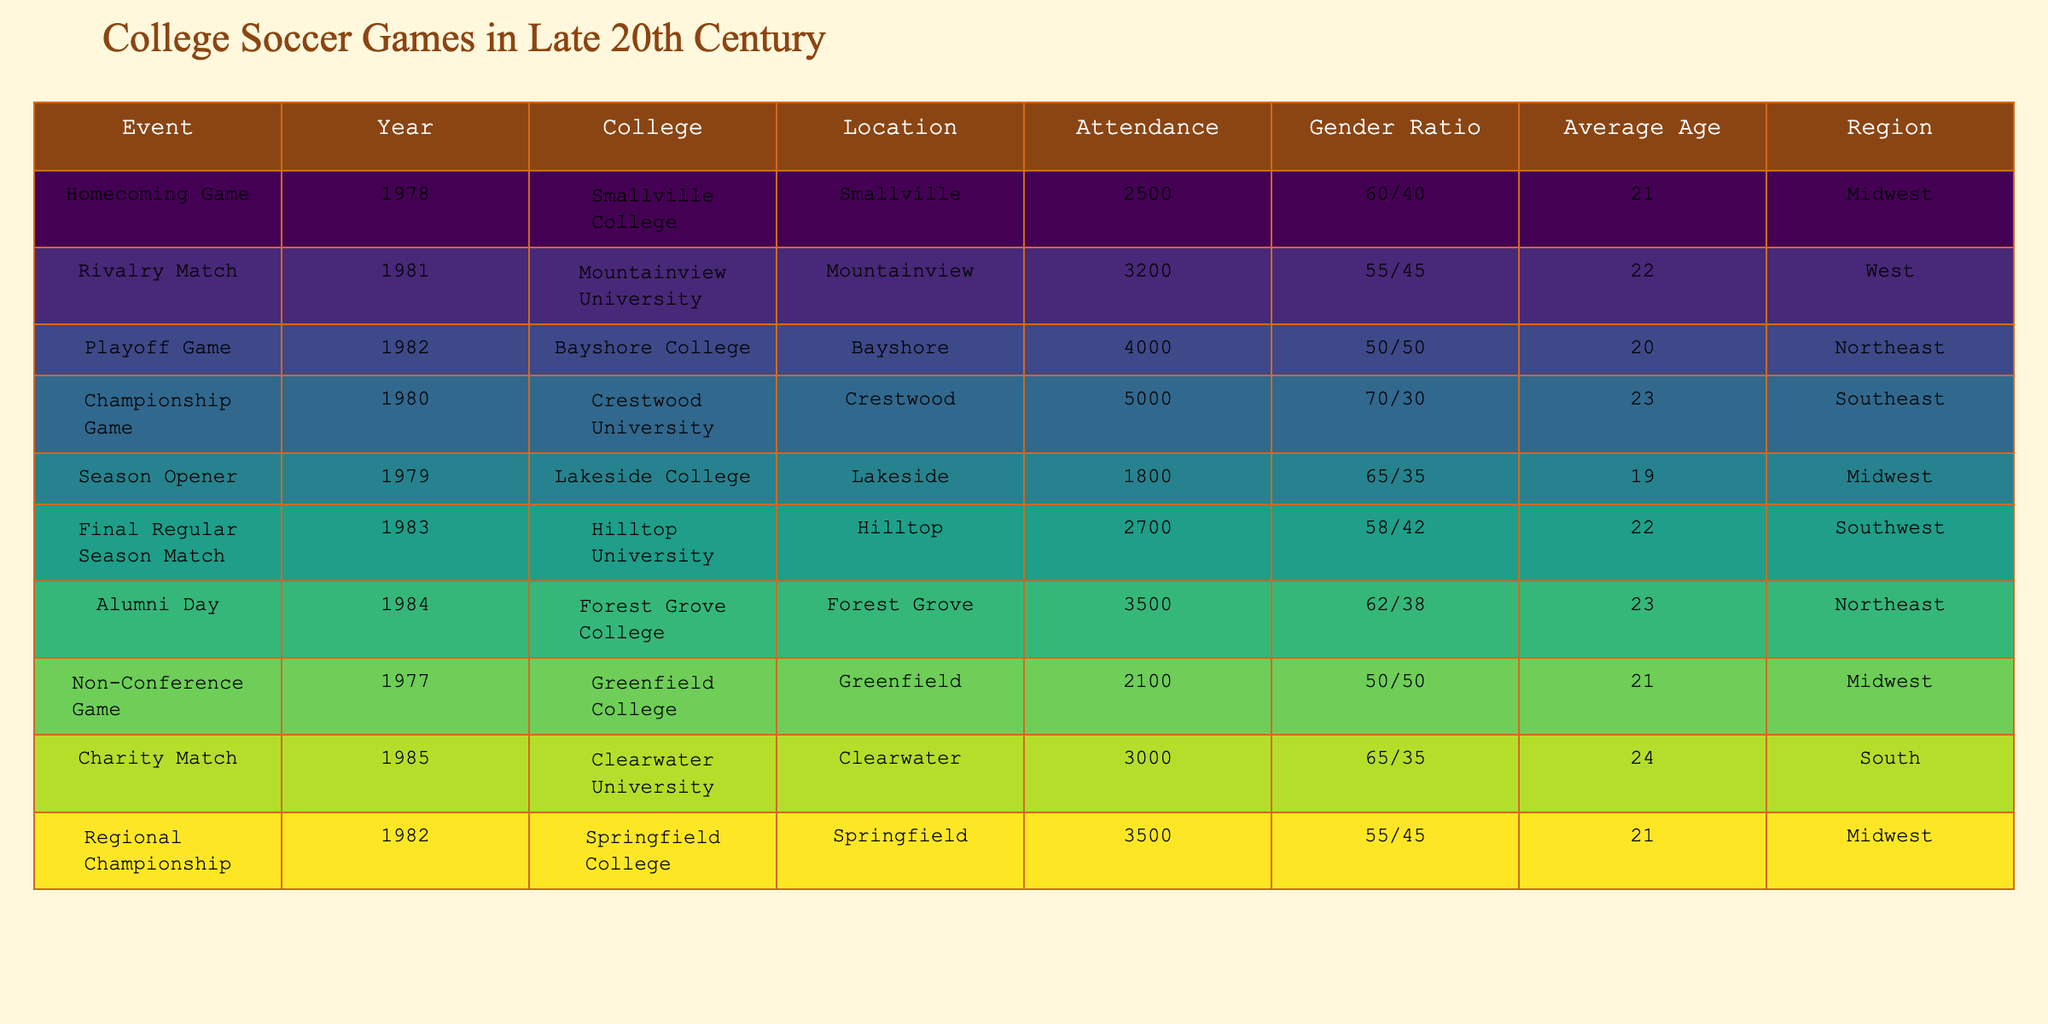What was the attendance for the Championship Game in 1980? The table lists the Championship Game in 1980 with an attendance of 5000.
Answer: 5000 What is the gender ratio for the Homecoming Game in 1978? The gender ratio for the Homecoming Game according to the table is 60/40.
Answer: 60/40 Which game had the highest average age of attendees, and what was it? The table indicates that the Championship Game in 1980 had the highest average age of 23 among attendees.
Answer: Championship Game, 23 Is the average age of attendees at the Rivalry Match in 1981 less than 22? The table shows the average age for the Rivalry Match in 1981 is 22, which is not less than 22.
Answer: No What is the total attendance for all events listed in the table? To find the total attendance, add all attendance figures: 2500 + 3200 + 4000 + 5000 + 1800 + 2700 + 3500 + 2100 + 3000 + 3500 = 32500.
Answer: 32500 Did more than half of the events have an attendance greater than 3000? By reviewing the table, 4 out of 10 events have attendance greater than 3000, which is not more than half.
Answer: No Which region had the most events listed in the table, and how many were there? Upon examining the table, the Midwest region has 4 events, which is the highest count compared to other regions.
Answer: Midwest, 4 What was the difference in attendance between the Playoff Game in 1982 and the Season Opener in 1979? The attendance for the Playoff Game in 1982 is 4000 and for the Season Opener in 1979 is 1800. Thus, 4000 - 1800 = 2200.
Answer: 2200 How many events had a gender ratio of at least 60% for males? The table shows that 6 out of 10 events had a gender ratio of at least 60% for males (Homecoming Game, Championship Game, Season Opener, Alumni Day, Charity Match).
Answer: 6 